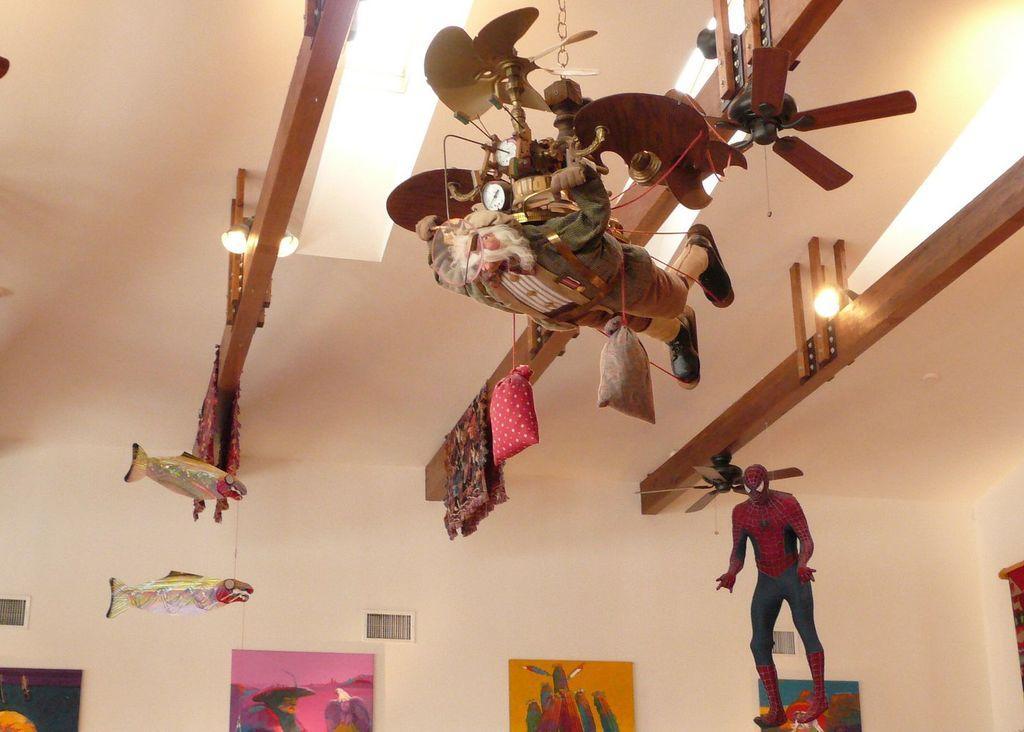Describe this image in one or two sentences. At the top we can see ceiling and lights. Here we can see toys. We can see pictures on a wall. 